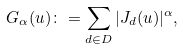<formula> <loc_0><loc_0><loc_500><loc_500>G _ { \alpha } ( u ) \colon = \sum _ { d \in D } | J _ { d } ( u ) | ^ { \alpha } ,</formula> 